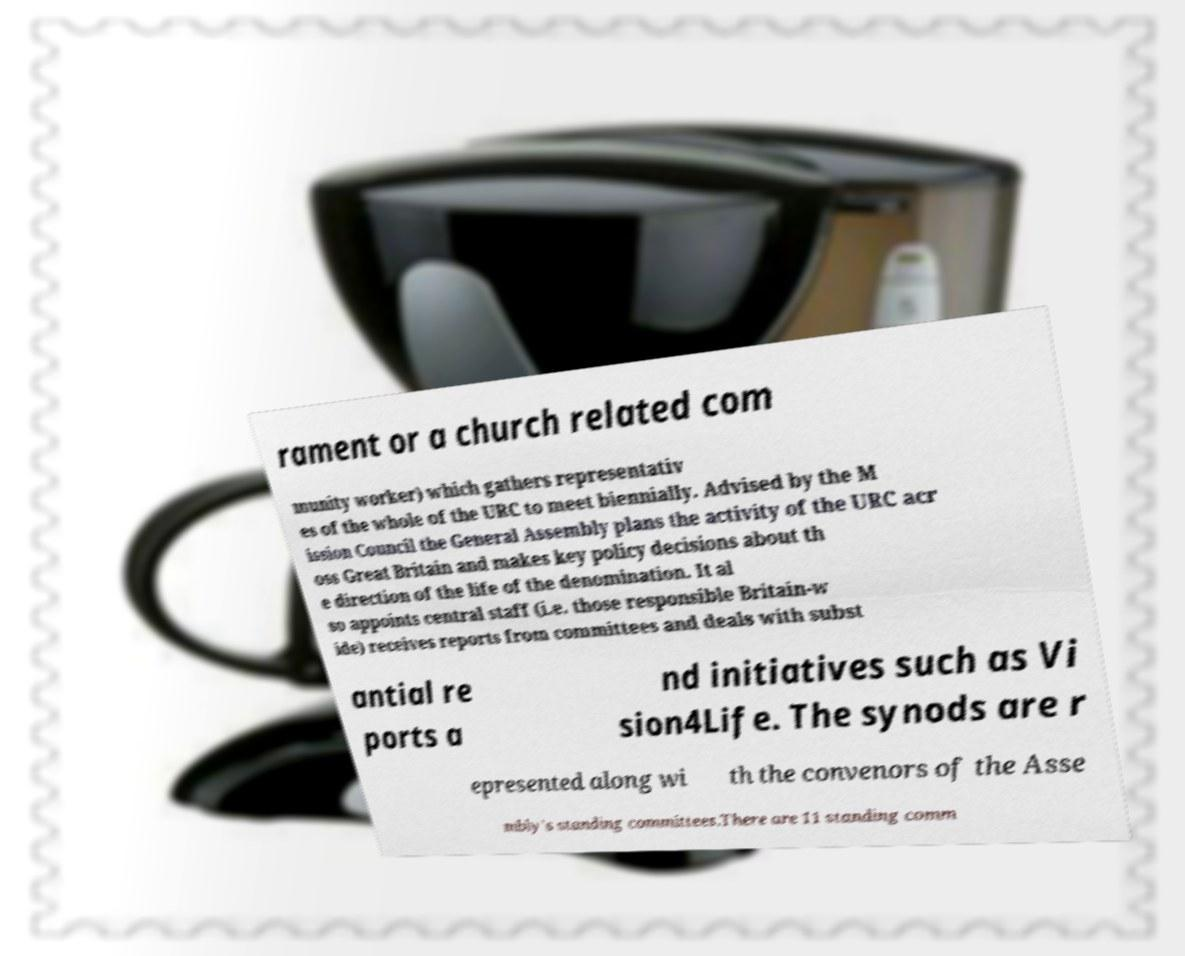Please identify and transcribe the text found in this image. rament or a church related com munity worker) which gathers representativ es of the whole of the URC to meet biennially. Advised by the M ission Council the General Assembly plans the activity of the URC acr oss Great Britain and makes key policy decisions about th e direction of the life of the denomination. It al so appoints central staff (i.e. those responsible Britain-w ide) receives reports from committees and deals with subst antial re ports a nd initiatives such as Vi sion4Life. The synods are r epresented along wi th the convenors of the Asse mbly's standing committees.There are 11 standing comm 